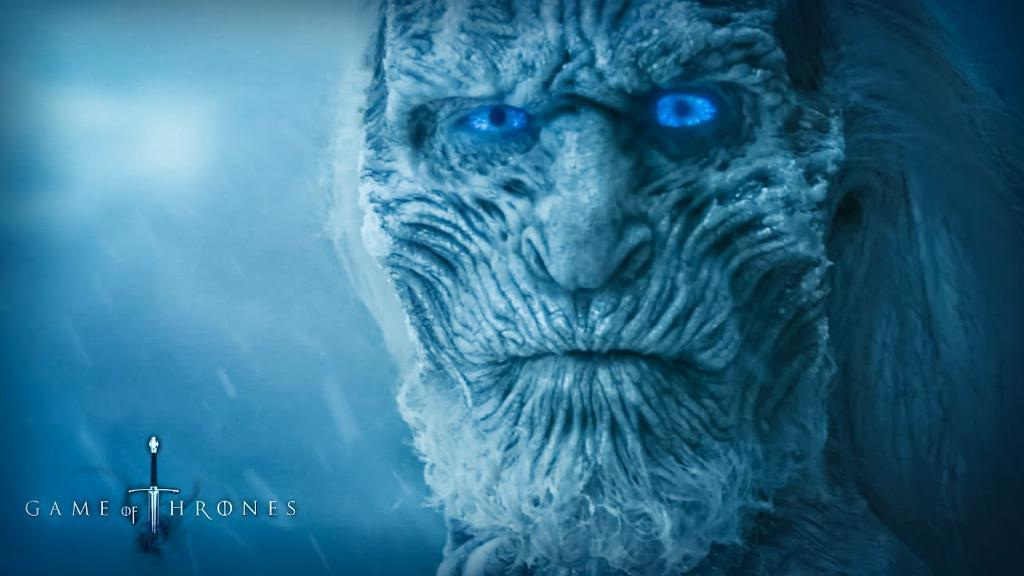What is the main subject of the image? There is a face in the image. What type of image is it? The image is an animated picture. Where can text be found in the image? There is text in the left bottom corner of the image. Is there a volcano erupting in the background of the image? No, there is no volcano present in the image. What type of cake is being served in the image? There is no cake present in the image. 